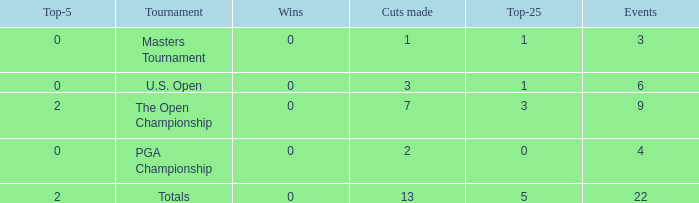How many total cuts were made in events with more than 0 wins and exactly 0 top-5s? 0.0. 